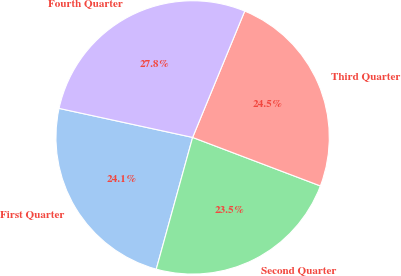<chart> <loc_0><loc_0><loc_500><loc_500><pie_chart><fcel>First Quarter<fcel>Second Quarter<fcel>Third Quarter<fcel>Fourth Quarter<nl><fcel>24.12%<fcel>23.51%<fcel>24.55%<fcel>27.82%<nl></chart> 